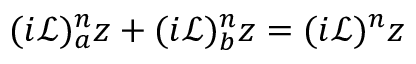Convert formula to latex. <formula><loc_0><loc_0><loc_500><loc_500>( i \mathcal { L } ) _ { a } ^ { n } z + ( i \mathcal { L } ) _ { b } ^ { n } z = ( i \mathcal { L } ) ^ { n } z</formula> 